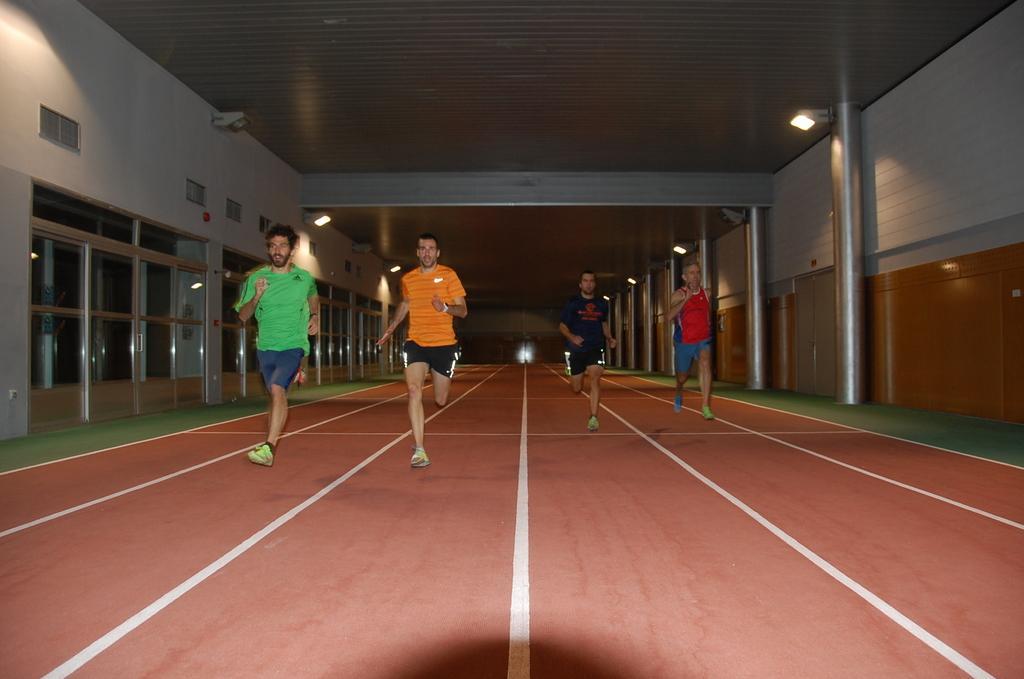How would you summarize this image in a sentence or two? In the center of the picture there are four people running on the track. In the foreground there is a shadow. On the right there are wall, pole and lights. On the left there are doors, glass windows, wall, ventilators and lights. In the background it is well. 